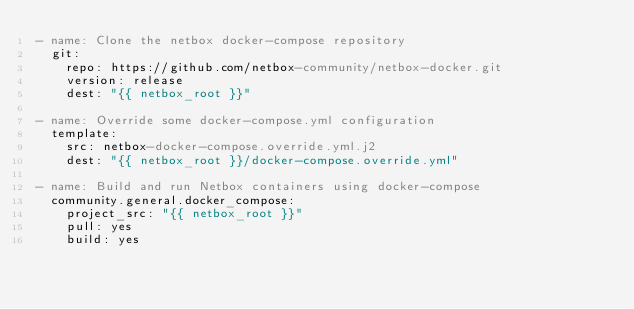Convert code to text. <code><loc_0><loc_0><loc_500><loc_500><_YAML_>- name: Clone the netbox docker-compose repository
  git: 
    repo: https://github.com/netbox-community/netbox-docker.git
    version: release
    dest: "{{ netbox_root }}"

- name: Override some docker-compose.yml configuration
  template:
    src: netbox-docker-compose.override.yml.j2
    dest: "{{ netbox_root }}/docker-compose.override.yml"

- name: Build and run Netbox containers using docker-compose
  community.general.docker_compose: 
    project_src: "{{ netbox_root }}"
    pull: yes
    build: yes
</code> 